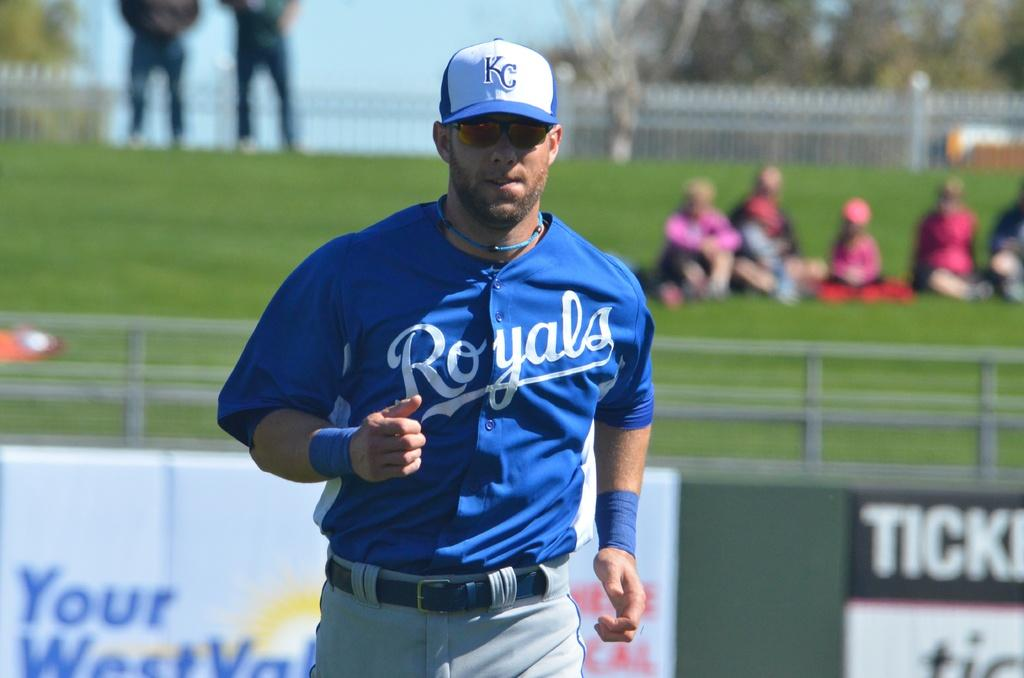Provide a one-sentence caption for the provided image. Man wearing a blue Royals jersey running on base. 